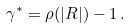<formula> <loc_0><loc_0><loc_500><loc_500>\gamma ^ { * } = \rho ( | R | ) - 1 \, .</formula> 